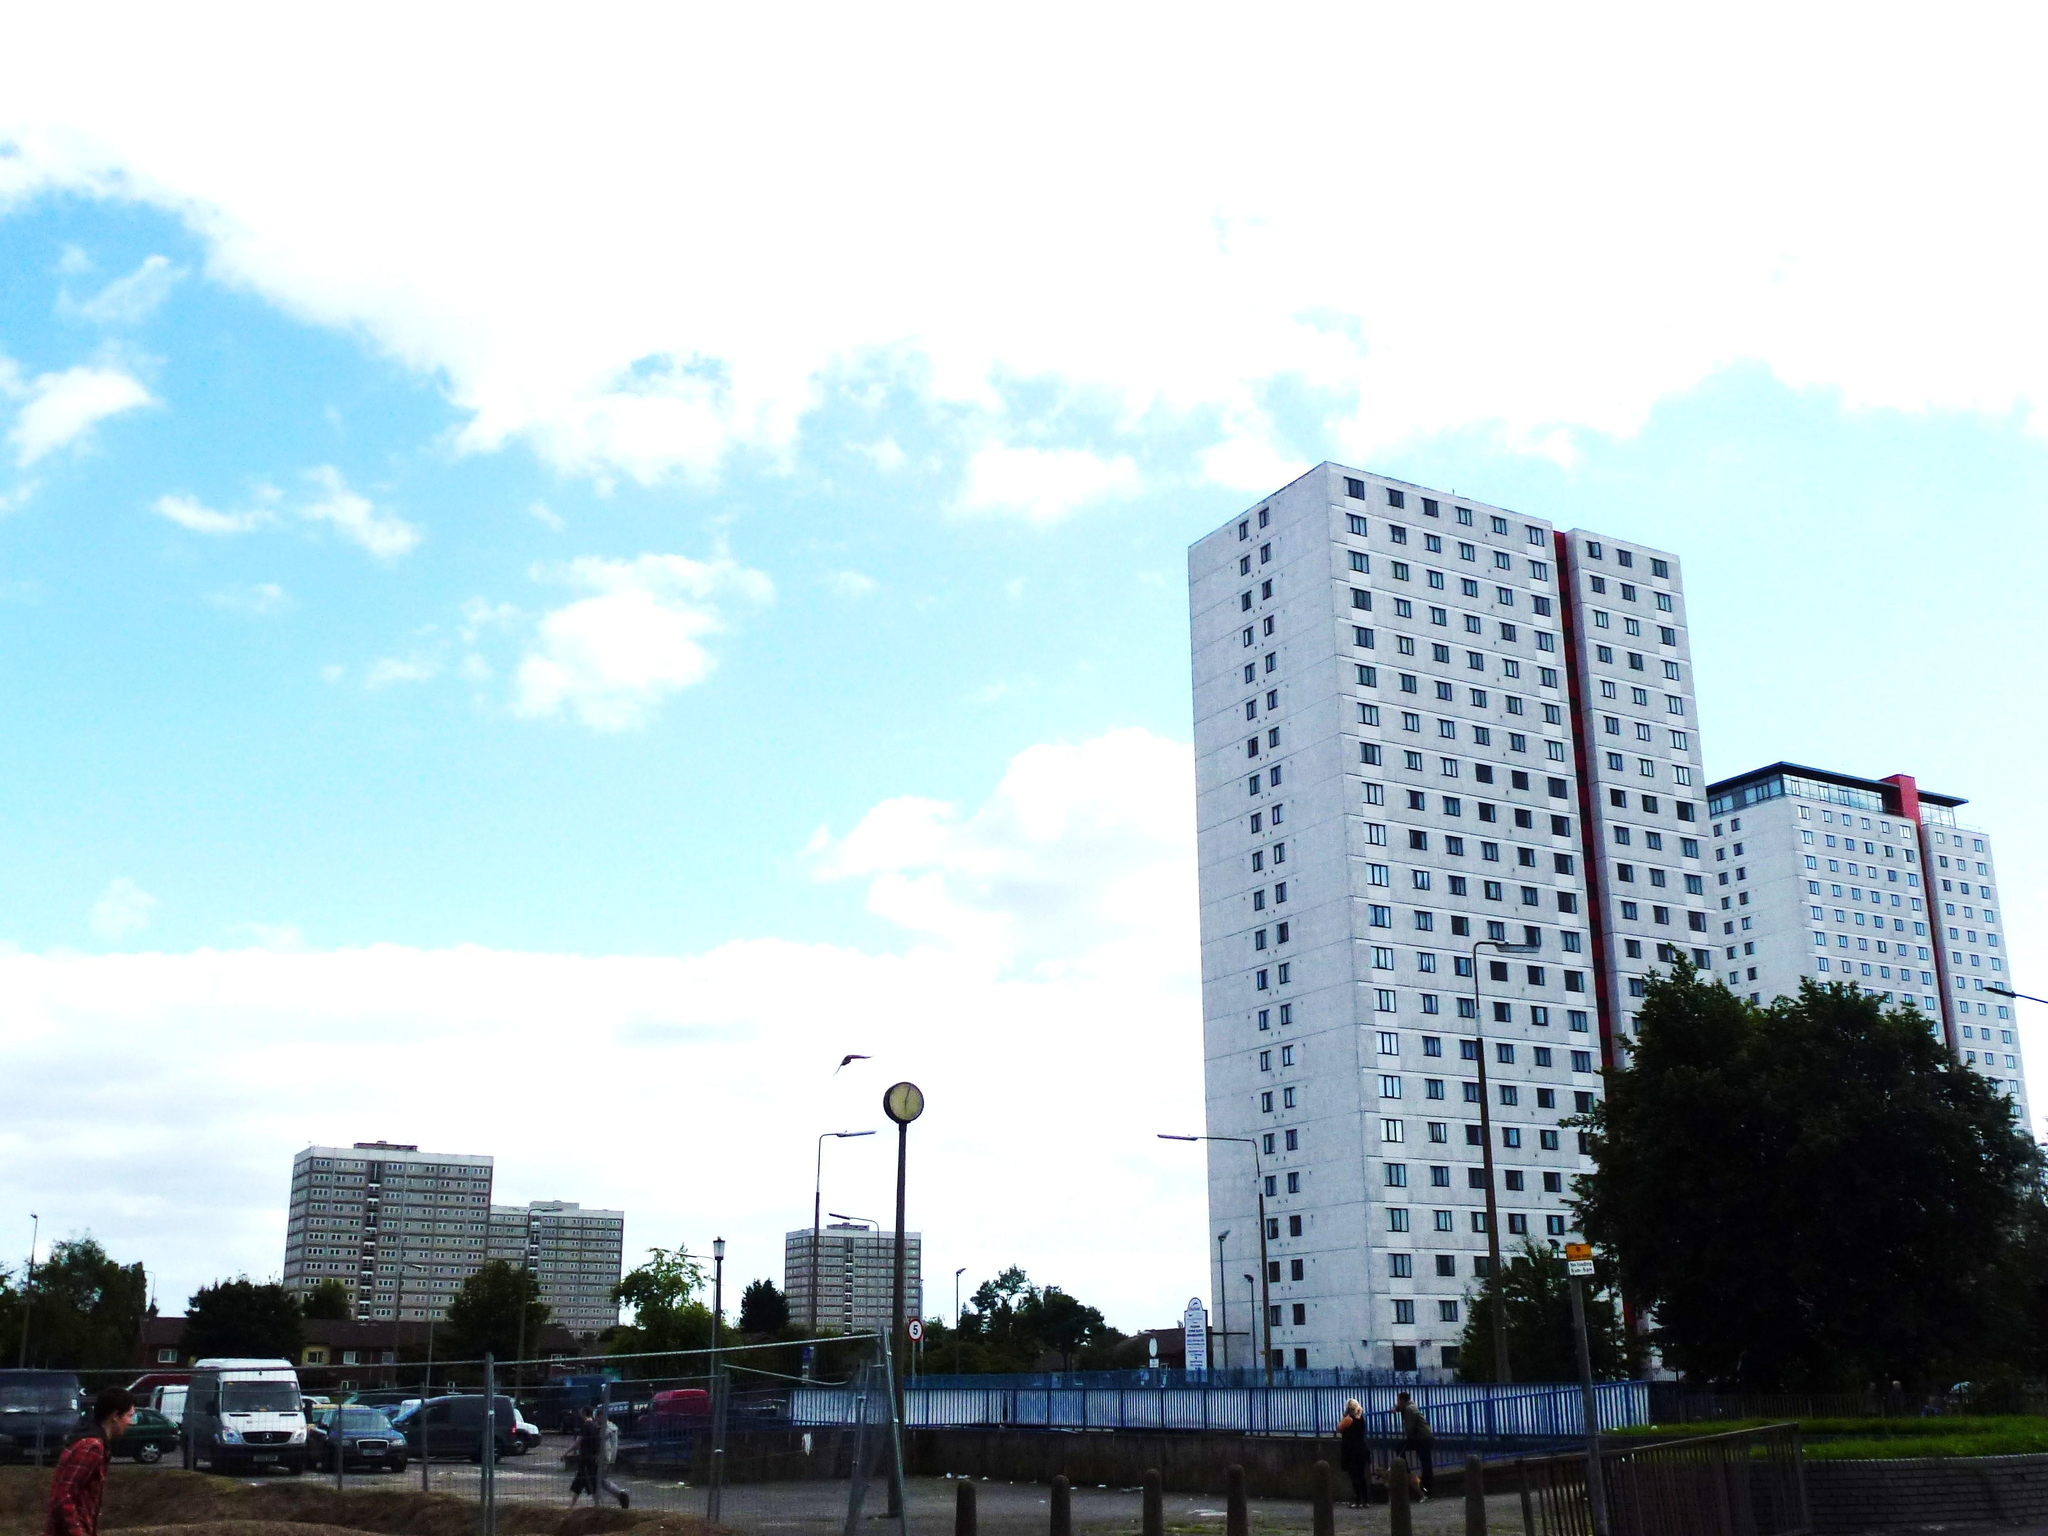What can be seen on the road in the image? There are vehicles on the road in the image. Who or what else can be seen in the image? There are people, fences, buildings, trees, light poles, and other objects in the image. What is visible in the background of the image? The sky is visible in the background of the image, with clouds present. What reason does the apparatus give for saying good-bye in the image? There is no apparatus or indication of anyone saying good-bye in the image. 